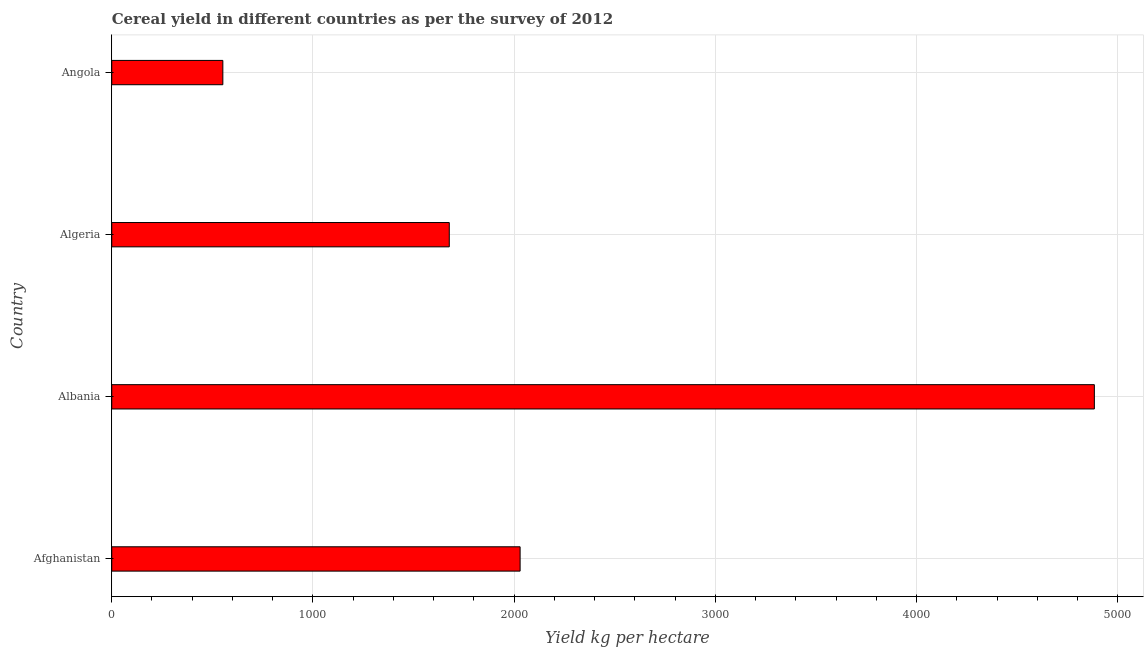Does the graph contain any zero values?
Keep it short and to the point. No. Does the graph contain grids?
Your answer should be compact. Yes. What is the title of the graph?
Keep it short and to the point. Cereal yield in different countries as per the survey of 2012. What is the label or title of the X-axis?
Your answer should be compact. Yield kg per hectare. What is the label or title of the Y-axis?
Give a very brief answer. Country. What is the cereal yield in Algeria?
Provide a succinct answer. 1677.56. Across all countries, what is the maximum cereal yield?
Ensure brevity in your answer.  4883.75. Across all countries, what is the minimum cereal yield?
Provide a short and direct response. 552.18. In which country was the cereal yield maximum?
Your answer should be compact. Albania. In which country was the cereal yield minimum?
Provide a short and direct response. Angola. What is the sum of the cereal yield?
Your response must be concise. 9143.08. What is the difference between the cereal yield in Afghanistan and Albania?
Make the answer very short. -2854.16. What is the average cereal yield per country?
Keep it short and to the point. 2285.77. What is the median cereal yield?
Ensure brevity in your answer.  1853.58. In how many countries, is the cereal yield greater than 4000 kg per hectare?
Ensure brevity in your answer.  1. What is the ratio of the cereal yield in Algeria to that in Angola?
Ensure brevity in your answer.  3.04. Is the cereal yield in Algeria less than that in Angola?
Ensure brevity in your answer.  No. What is the difference between the highest and the second highest cereal yield?
Your response must be concise. 2854.16. Is the sum of the cereal yield in Albania and Angola greater than the maximum cereal yield across all countries?
Provide a succinct answer. Yes. What is the difference between the highest and the lowest cereal yield?
Ensure brevity in your answer.  4331.58. Are all the bars in the graph horizontal?
Provide a short and direct response. Yes. What is the Yield kg per hectare in Afghanistan?
Ensure brevity in your answer.  2029.59. What is the Yield kg per hectare in Albania?
Provide a succinct answer. 4883.75. What is the Yield kg per hectare in Algeria?
Give a very brief answer. 1677.56. What is the Yield kg per hectare in Angola?
Your answer should be compact. 552.18. What is the difference between the Yield kg per hectare in Afghanistan and Albania?
Keep it short and to the point. -2854.16. What is the difference between the Yield kg per hectare in Afghanistan and Algeria?
Your answer should be very brief. 352.03. What is the difference between the Yield kg per hectare in Afghanistan and Angola?
Provide a short and direct response. 1477.41. What is the difference between the Yield kg per hectare in Albania and Algeria?
Make the answer very short. 3206.19. What is the difference between the Yield kg per hectare in Albania and Angola?
Keep it short and to the point. 4331.58. What is the difference between the Yield kg per hectare in Algeria and Angola?
Your answer should be very brief. 1125.39. What is the ratio of the Yield kg per hectare in Afghanistan to that in Albania?
Your answer should be very brief. 0.42. What is the ratio of the Yield kg per hectare in Afghanistan to that in Algeria?
Offer a terse response. 1.21. What is the ratio of the Yield kg per hectare in Afghanistan to that in Angola?
Offer a terse response. 3.68. What is the ratio of the Yield kg per hectare in Albania to that in Algeria?
Your answer should be very brief. 2.91. What is the ratio of the Yield kg per hectare in Albania to that in Angola?
Ensure brevity in your answer.  8.85. What is the ratio of the Yield kg per hectare in Algeria to that in Angola?
Make the answer very short. 3.04. 